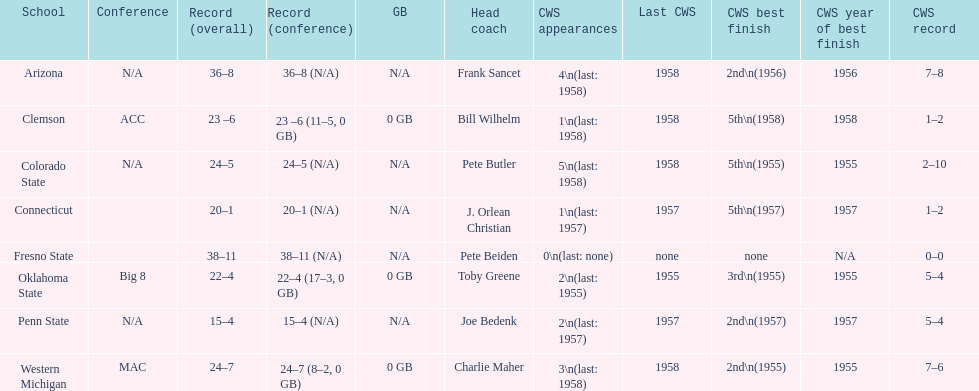Does clemson or western michigan have more cws appearances? Western Michigan. Would you mind parsing the complete table? {'header': ['School', 'Conference', 'Record (overall)', 'Record (conference)', 'GB', 'Head coach', 'CWS appearances', 'Last CWS', 'CWS best finish', 'CWS year of best finish', 'CWS record'], 'rows': [['Arizona', 'N/A', '36–8', '36–8 (N/A)', 'N/A', 'Frank Sancet', '4\\n(last: 1958)', '1958', '2nd\\n(1956)', '1956', '7–8'], ['Clemson', 'ACC', '23 –6', '23 –6 (11–5, 0 GB)', '0 GB', 'Bill Wilhelm', '1\\n(last: 1958)', '1958', '5th\\n(1958)', '1958', '1–2'], ['Colorado State', 'N/A', '24–5', '24–5 (N/A)', 'N/A', 'Pete Butler', '5\\n(last: 1958)', '1958', '5th\\n(1955)', '1955', '2–10'], ['Connecticut', '', '20–1', '20–1 (N/A)', 'N/A', 'J. Orlean Christian', '1\\n(last: 1957)', '1957', '5th\\n(1957)', '1957', '1–2'], ['Fresno State', '', '38–11', '38–11 (N/A)', 'N/A', 'Pete Beiden', '0\\n(last: none)', 'none', 'none', 'N/A', '0–0'], ['Oklahoma State', 'Big 8', '22–4', '22–4 (17–3, 0 GB)', '0 GB', 'Toby Greene', '2\\n(last: 1955)', '1955', '3rd\\n(1955)', '1955', '5–4'], ['Penn State', 'N/A', '15–4', '15–4 (N/A)', 'N/A', 'Joe Bedenk', '2\\n(last: 1957)', '1957', '2nd\\n(1957)', '1957', '5–4'], ['Western Michigan', 'MAC', '24–7', '24–7 (8–2, 0 GB)', '0 GB', 'Charlie Maher', '3\\n(last: 1958)', '1958', '2nd\\n(1955)', '1955', '7–6']]} 